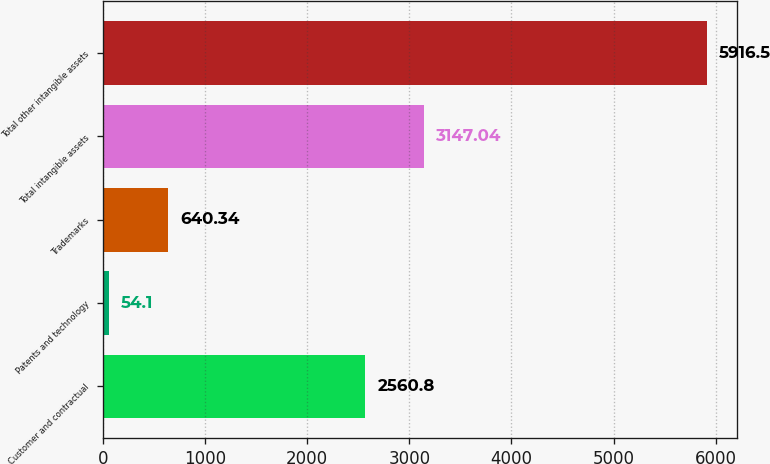Convert chart. <chart><loc_0><loc_0><loc_500><loc_500><bar_chart><fcel>Customer and contractual<fcel>Patents and technology<fcel>Trademarks<fcel>Total intangible assets<fcel>Total other intangible assets<nl><fcel>2560.8<fcel>54.1<fcel>640.34<fcel>3147.04<fcel>5916.5<nl></chart> 